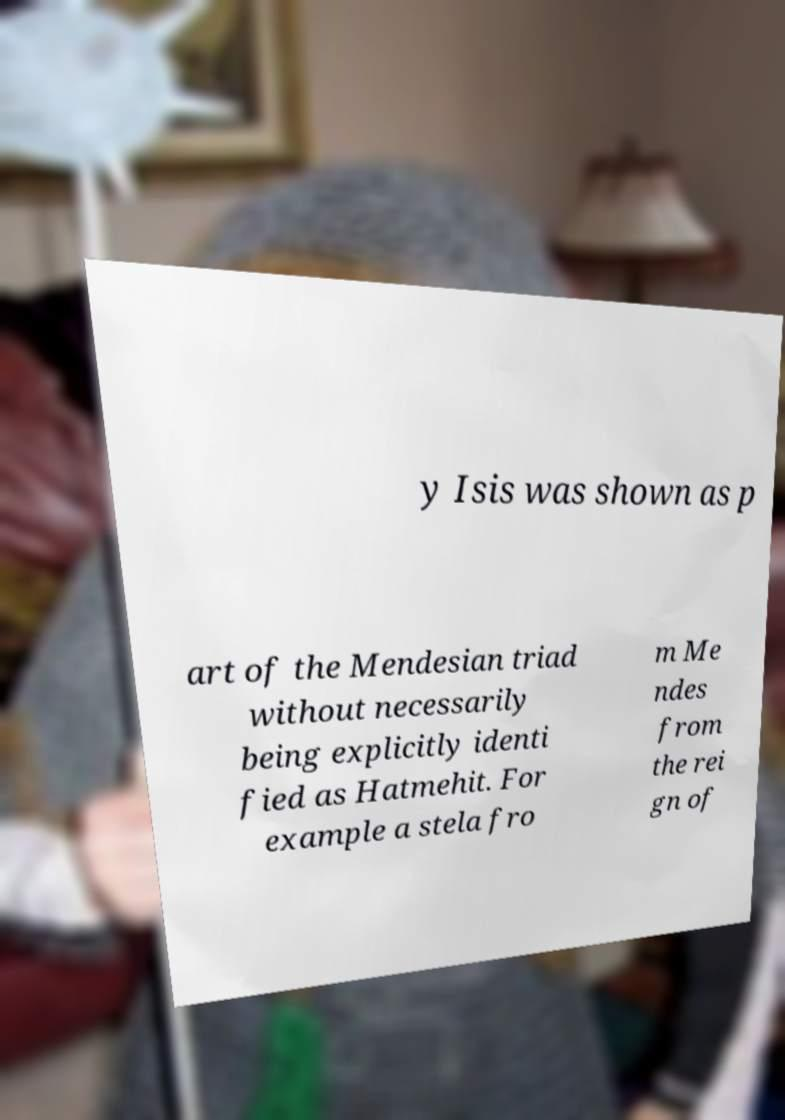I need the written content from this picture converted into text. Can you do that? y Isis was shown as p art of the Mendesian triad without necessarily being explicitly identi fied as Hatmehit. For example a stela fro m Me ndes from the rei gn of 